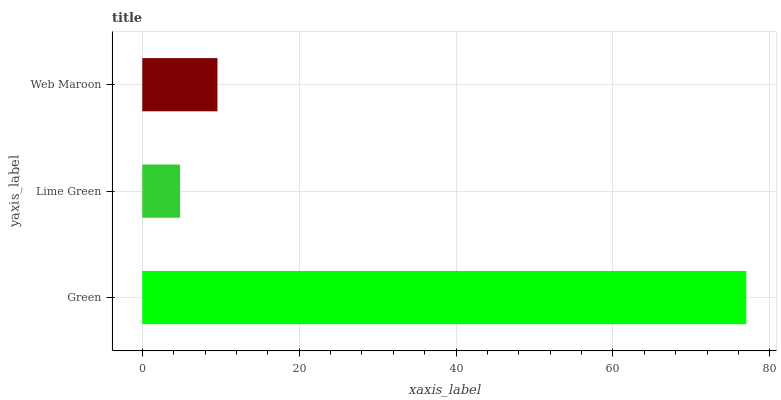Is Lime Green the minimum?
Answer yes or no. Yes. Is Green the maximum?
Answer yes or no. Yes. Is Web Maroon the minimum?
Answer yes or no. No. Is Web Maroon the maximum?
Answer yes or no. No. Is Web Maroon greater than Lime Green?
Answer yes or no. Yes. Is Lime Green less than Web Maroon?
Answer yes or no. Yes. Is Lime Green greater than Web Maroon?
Answer yes or no. No. Is Web Maroon less than Lime Green?
Answer yes or no. No. Is Web Maroon the high median?
Answer yes or no. Yes. Is Web Maroon the low median?
Answer yes or no. Yes. Is Green the high median?
Answer yes or no. No. Is Lime Green the low median?
Answer yes or no. No. 